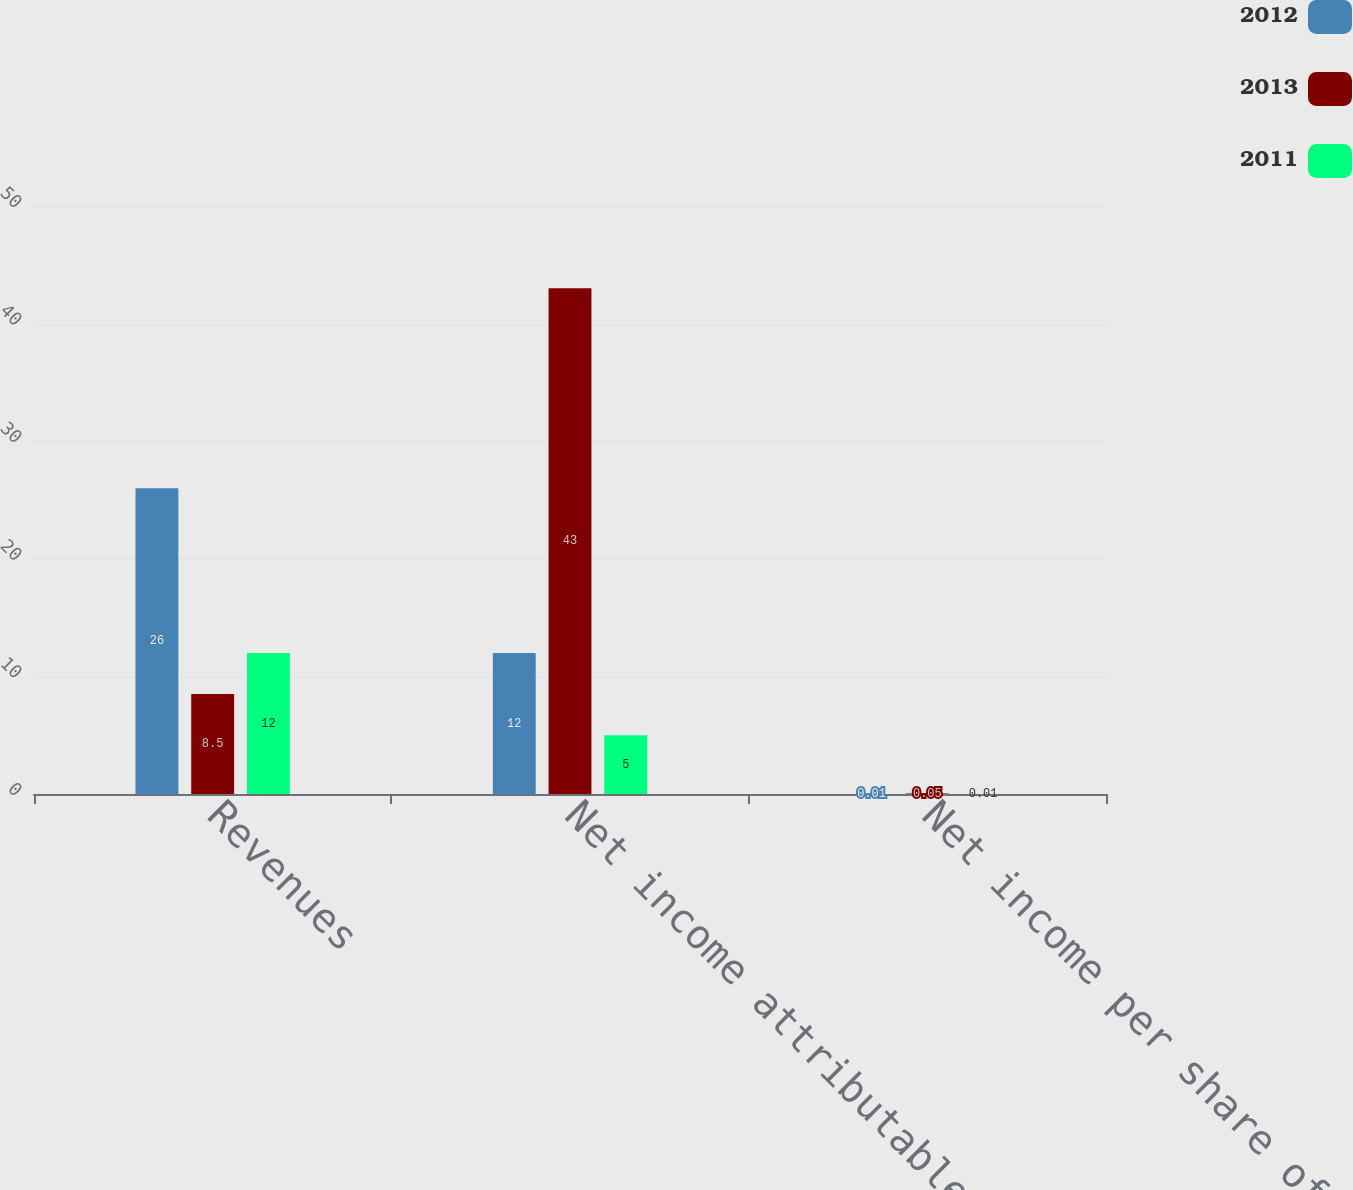<chart> <loc_0><loc_0><loc_500><loc_500><stacked_bar_chart><ecel><fcel>Revenues<fcel>Net income attributable to FCX<fcel>Net income per share of FCX<nl><fcel>2012<fcel>26<fcel>12<fcel>0.01<nl><fcel>2013<fcel>8.5<fcel>43<fcel>0.05<nl><fcel>2011<fcel>12<fcel>5<fcel>0.01<nl></chart> 